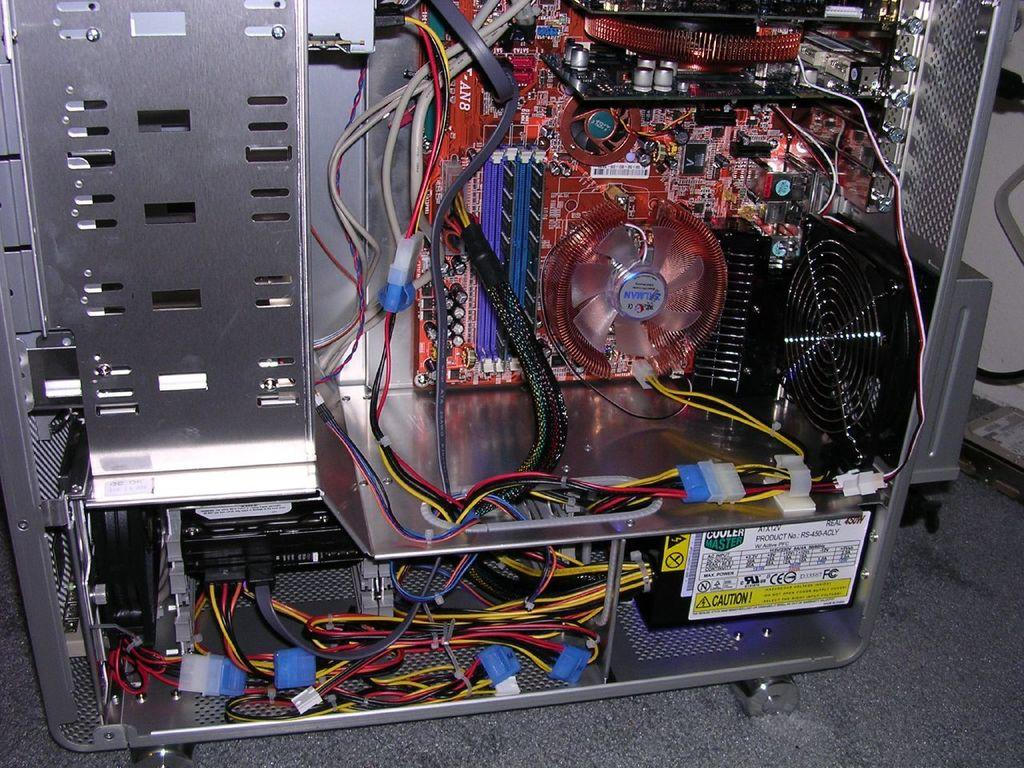What is the main subject of the image? The main subject of the image is an inside view of a CPU. Can you describe the background of the image? There is a wall behind the CPU in the image. What type of game is being played on the CPU in the image? There is no game being played on the CPU in the image; it is an inside view of the CPU's components. Can you see any steam coming from the CPU in the image? There is no steam visible in the image; it shows an inside view of the CPU's components. 